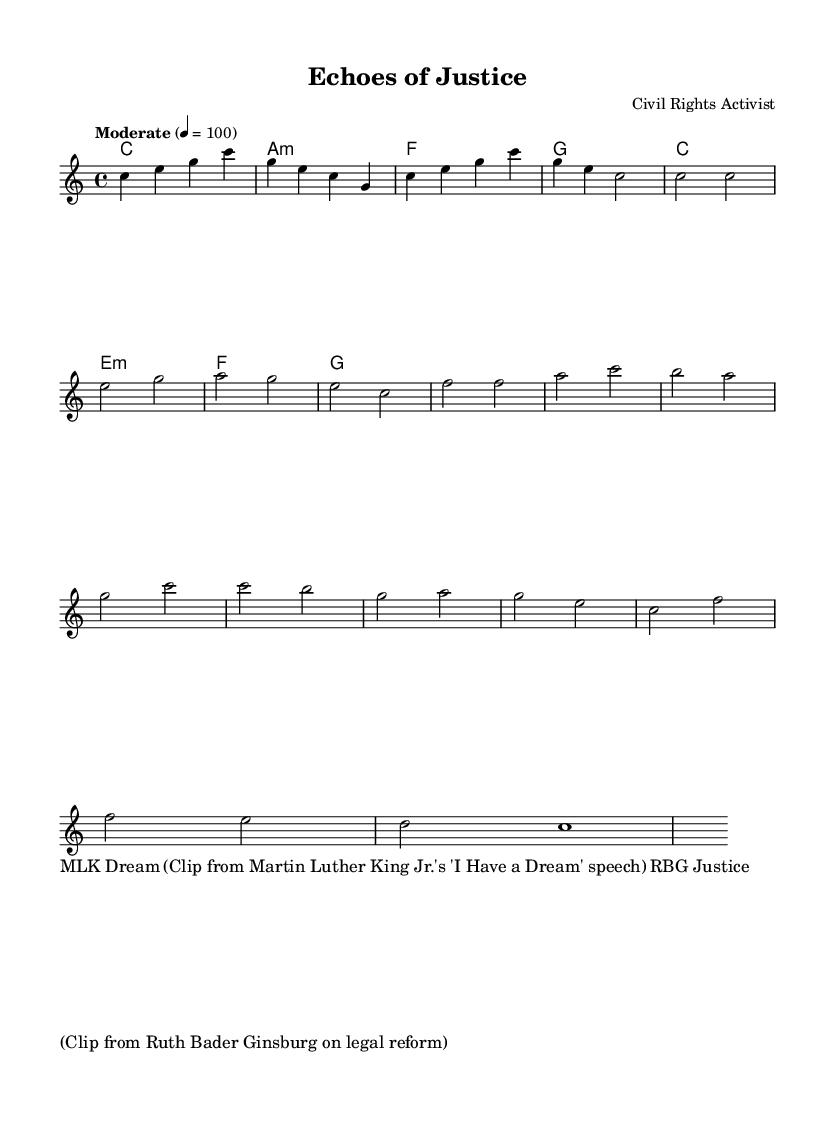What is the key signature of this music? The key signature is C major, which has no sharps or flats.
Answer: C major What is the time signature of the piece? The time signature is given as 4/4, which indicates four beats per measure.
Answer: 4/4 What is the tempo marking for the music? The tempo marking indicates "Moderate" with a metronome marking of 100 beats per minute.
Answer: Moderate 4 = 100 How many measures are in the chorus section? The chorus section consists of four measures as indicated in the music.
Answer: 4 What is the name of the piece? The title of the piece is "Echoes of Justice," which reflects its theme.
Answer: Echoes of Justice What is the first melody note in the piece? The first melody note is C, which is the starting note of the intro.
Answer: C How many chord changes occur in the harmony section? There are seven chord changes throughout the harmony section indicated in the score.
Answer: 7 